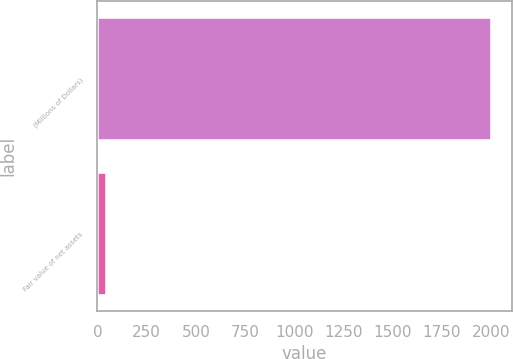Convert chart to OTSL. <chart><loc_0><loc_0><loc_500><loc_500><bar_chart><fcel>(Millions of Dollars)<fcel>Fair value of net assets<nl><fcel>2004<fcel>49<nl></chart> 